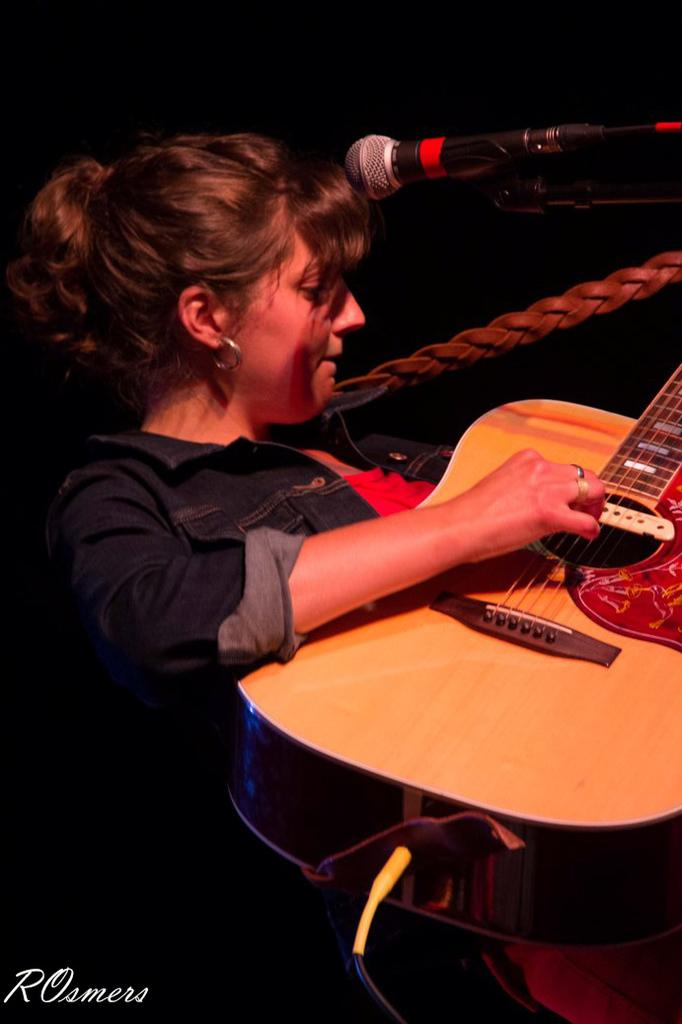What is the woman in the image doing? The woman is playing a guitar in the image. What object is present near the woman? There is a microphone in the top right corner of the image. How would you describe the lighting in the image? The background of the image is dark. What is the woman wearing in the image? The woman is wearing a denim shirt. Can you describe any other objects in the foreground of the image? A cable is visible in the foreground of the image. What type of scarf is the woman wearing in the image? There is no scarf visible in the image; the woman is wearing a denim shirt. What sound do the bells make in the image? There are no bells present in the image. 